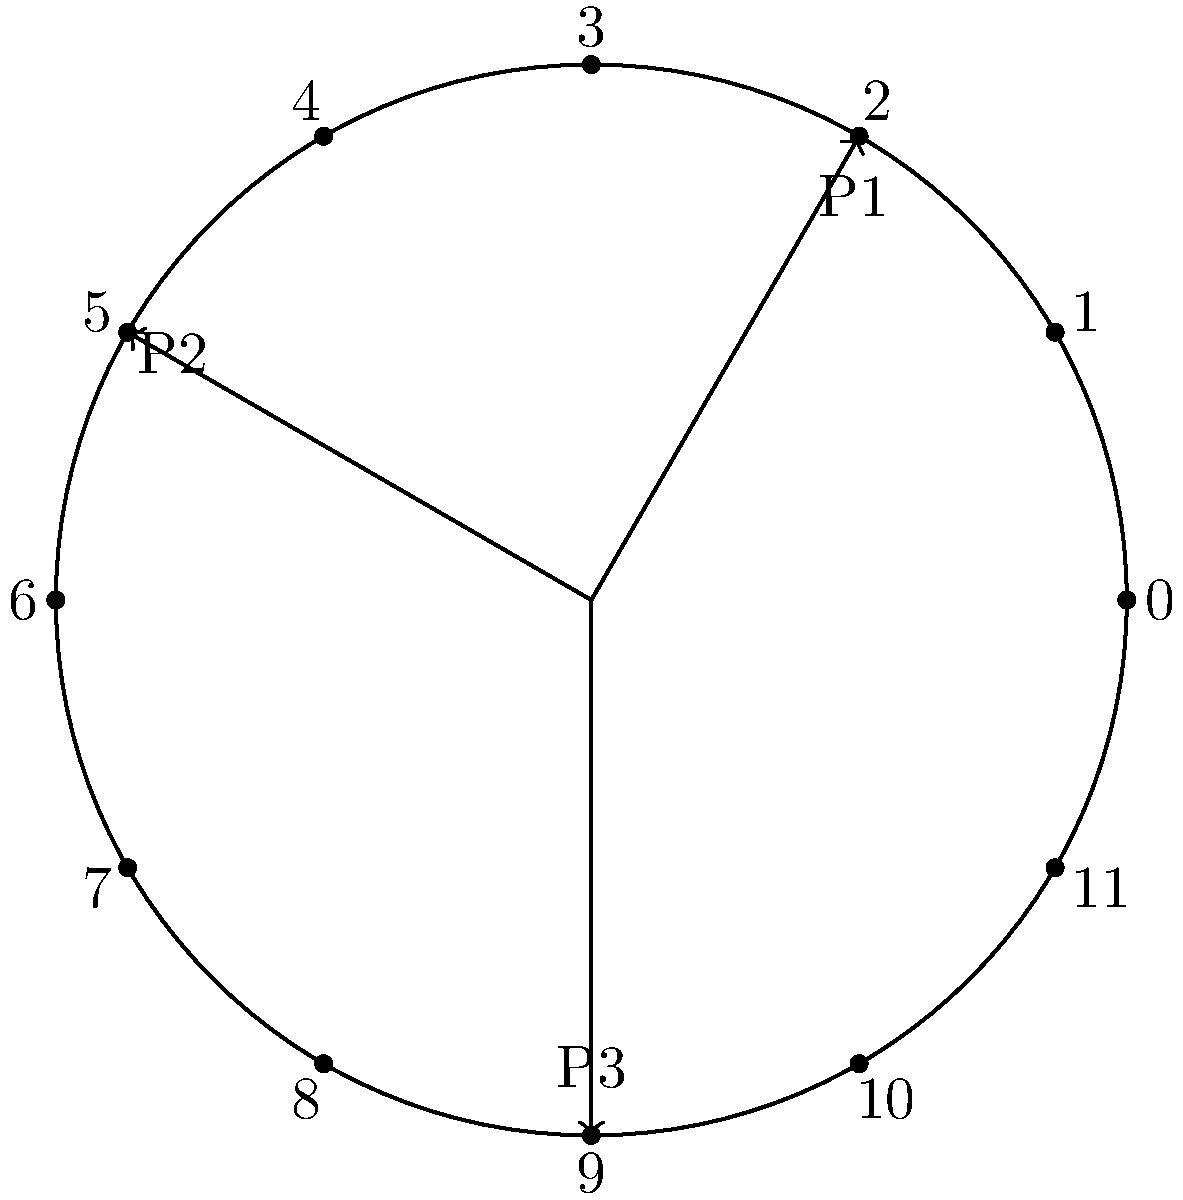In a circular timeline representation of process scheduling using polar coordinates, three processes (P1, P2, and P3) are scheduled as shown in the diagram. P1 starts at 2 o'clock, P2 at 5 o'clock, and P3 at 9 o'clock. If each process runs for exactly one-third of the total cycle time, what is the angular difference (in radians) between the start of P1 and the end of P3? To solve this problem, we'll follow these steps:

1. Understand the circular representation:
   - The circle is divided into 12 equal parts, like a clock.
   - Each part represents 30 degrees or $\frac{\pi}{6}$ radians.

2. Calculate the starting positions of processes:
   - P1 starts at 2 o'clock: $2 \times \frac{\pi}{6} = \frac{\pi}{3}$ radians
   - P2 starts at 5 o'clock: $5 \times \frac{\pi}{6} = \frac{5\pi}{6}$ radians
   - P3 starts at 9 o'clock: $9 \times \frac{\pi}{6} = \frac{3\pi}{2}$ radians

3. Calculate the duration of each process:
   - Each process runs for 1/3 of the total cycle.
   - Total cycle = $2\pi$ radians
   - Duration of each process = $\frac{1}{3} \times 2\pi = \frac{2\pi}{3}$ radians

4. Calculate the end position of P3:
   - P3 starts at $\frac{3\pi}{2}$ radians
   - P3 ends at $\frac{3\pi}{2} + \frac{2\pi}{3} = \frac{13\pi}{6}$ radians

5. Calculate the angular difference between P1 start and P3 end:
   - Angular difference = P3 end - P1 start
   - $\frac{13\pi}{6} - \frac{\pi}{3} = \frac{13\pi}{6} - \frac{2\pi}{6} = \frac{11\pi}{6}$ radians

Therefore, the angular difference between the start of P1 and the end of P3 is $\frac{11\pi}{6}$ radians.
Answer: $\frac{11\pi}{6}$ radians 